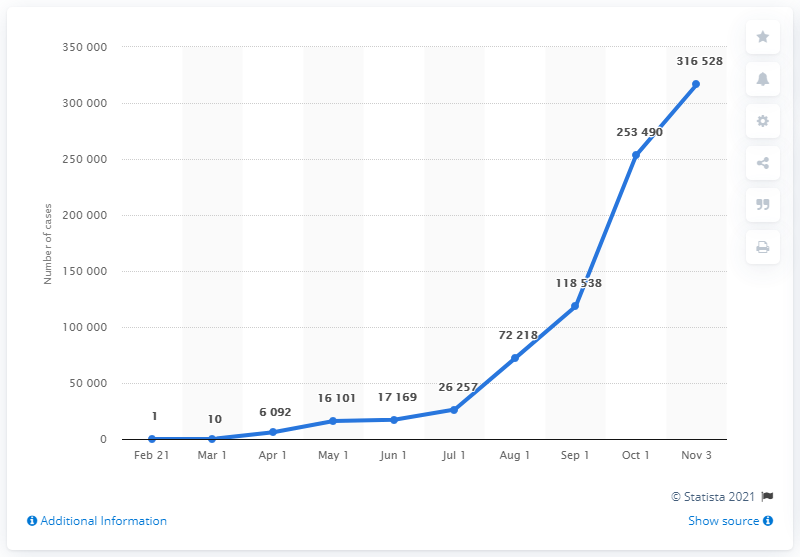Outline some significant characteristics in this image. As of November 3, 2020, there were 31,6528 cases of COVID-19 in Israel. 